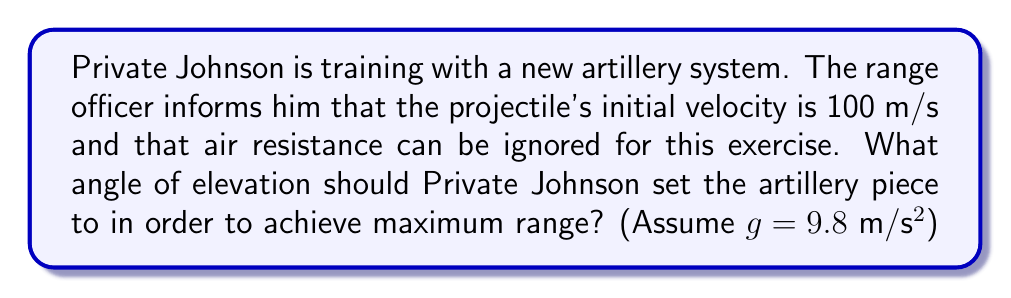Can you answer this question? To solve this problem, we need to understand the principles of projectile motion and the conditions for maximum range.

1) In projectile motion without air resistance, the range (R) is given by the equation:

   $$R = \frac{v_0^2 \sin(2\theta)}{g}$$

   Where $v_0$ is the initial velocity, $\theta$ is the angle of elevation, and $g$ is the acceleration due to gravity.

2) To find the maximum range, we need to maximize $\sin(2\theta)$. The sine function reaches its maximum value of 1 when its argument is 90°.

3) Therefore, for maximum range:

   $$2\theta = 90°$$
   $$\theta = 45°$$

4) We can verify this mathematically by taking the derivative of the range equation with respect to $\theta$, setting it to zero, and solving for $\theta$:

   $$\frac{dR}{d\theta} = \frac{v_0^2}{g} \cdot 2\cos(2\theta) = 0$$

   This is true when $\cos(2\theta) = 0$, which occurs when $2\theta = 90°$ or $\theta = 45°$.

5) Therefore, the optimal angle for maximum range is always 45°, regardless of the initial velocity or the value of g (assuming no air resistance).

This result aligns with the physical intuition that a 45° angle balances the trade-off between vertical height (which provides time in the air) and horizontal velocity (which provides forward motion).
Answer: The optimal angle of elevation for maximum range is 45°. 